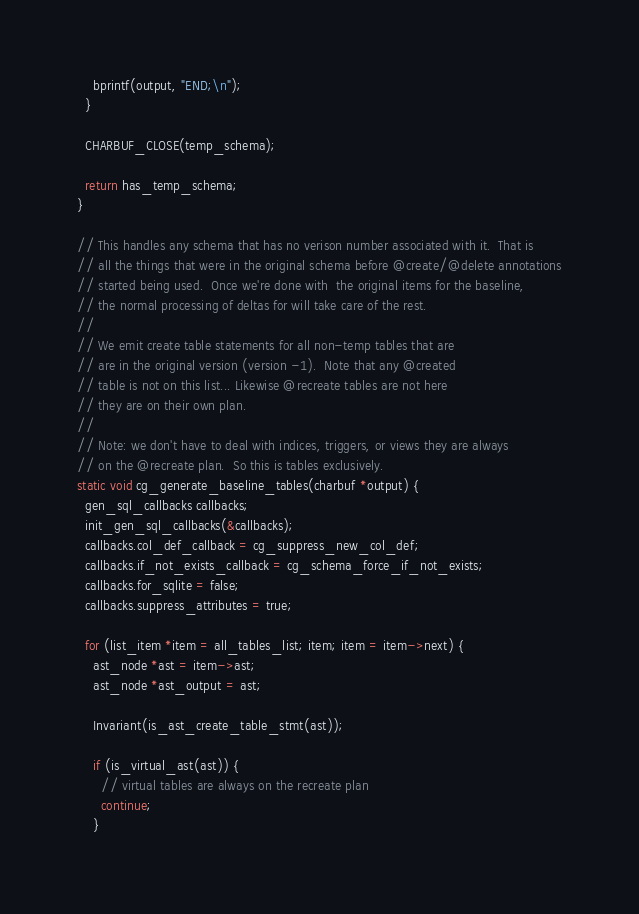Convert code to text. <code><loc_0><loc_0><loc_500><loc_500><_C_>    bprintf(output, "END;\n");
  }

  CHARBUF_CLOSE(temp_schema);

  return has_temp_schema;
}

// This handles any schema that has no verison number associated with it.  That is
// all the things that were in the original schema before @create/@delete annotations
// started being used.  Once we're done with  the original items for the baseline,
// the normal processing of deltas for will take care of the rest.
//
// We emit create table statements for all non-temp tables that are
// are in the original version (version -1).  Note that any @created
// table is not on this list... Likewise @recreate tables are not here
// they are on their own plan.
//
// Note: we don't have to deal with indices, triggers, or views they are always
// on the @recreate plan.  So this is tables exclusively.
static void cg_generate_baseline_tables(charbuf *output) {
  gen_sql_callbacks callbacks;
  init_gen_sql_callbacks(&callbacks);
  callbacks.col_def_callback = cg_suppress_new_col_def;
  callbacks.if_not_exists_callback = cg_schema_force_if_not_exists;
  callbacks.for_sqlite = false;
  callbacks.suppress_attributes = true;

  for (list_item *item = all_tables_list; item; item = item->next) {
    ast_node *ast = item->ast;
    ast_node *ast_output = ast;

    Invariant(is_ast_create_table_stmt(ast));

    if (is_virtual_ast(ast)) {
      // virtual tables are always on the recreate plan
      continue;
    }
</code> 